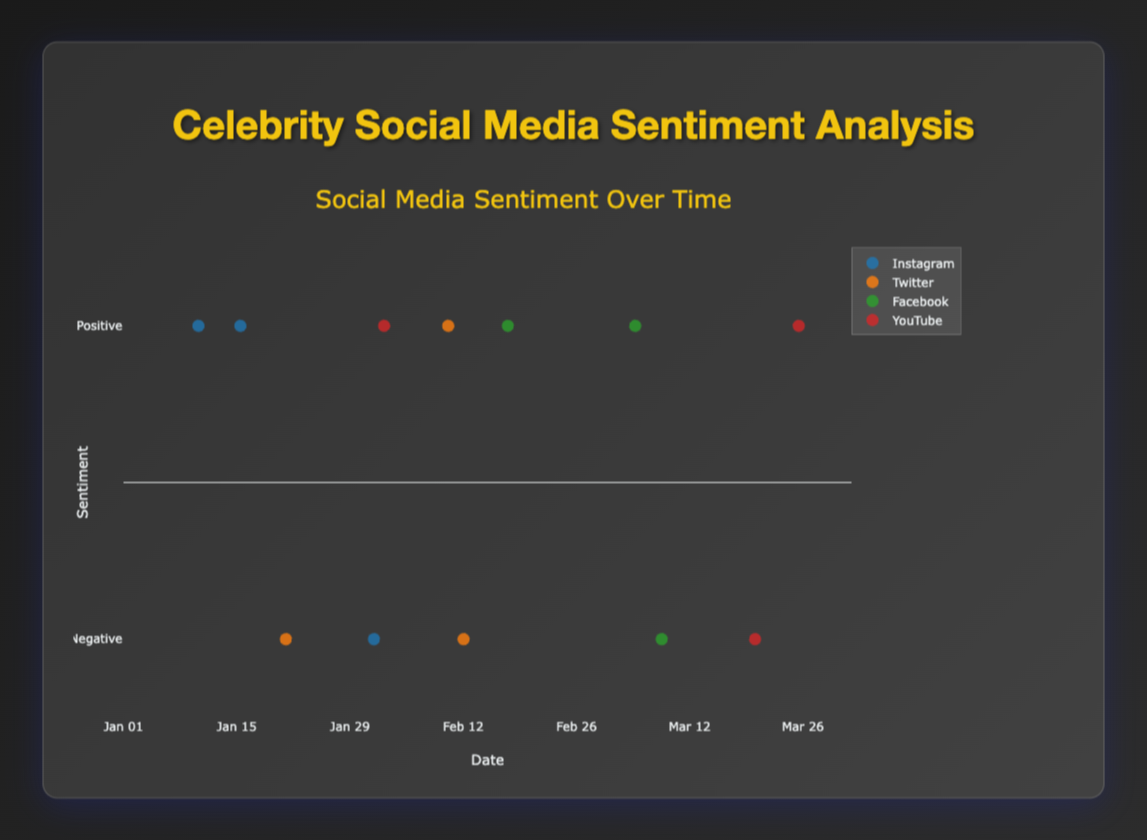What's the title of the figure? The title of the figure is displayed at the top and reads "Celebrity Social Media Sentiment Analysis". It provides a summary of what the plot represents.
Answer: Celebrity Social Media Sentiment Analysis Which platforms have negative comments? By looking at the scatter plot, we can identify the platforms with negative comments by observing the y-values at -1. The platforms listed are Instagram, Twitter, Facebook, and YouTube.
Answer: Instagram, Twitter, Facebook, YouTube What is the date range displayed on the x-axis? The x-axis title is "Date" and the ticks range from January to April 2023, as seen by the notations "%b %d" format (e.g., Jan 01 to Apr 01).
Answer: January to April 2023 How many positive comments are there on Twitter, compared to the total number of comments? Markers at y=1 represent positive sentiments. On Twitter, there's 1 positive comment. The total number of comments on Twitter is 3, considering both positive and negative sentiments (positive=1, negative=2).
Answer: 1 positive out of 3 total comments Are there more positive or negative comments overall? By counting all positive (y=1) and negative (y=-1) markers across all platforms:
- Positive: 7 comments
- Negative: 5 comments
Positive comments outnumber negative comments.
Answer: More positive comments What's the ratio of positive to negative comments on Instagram? On Instagram, by counting from the scatter plot:
- Positive: 2
- Negative: 1
The ratio of positive to negative comments is therefore 2:1.
Answer: 2:1 